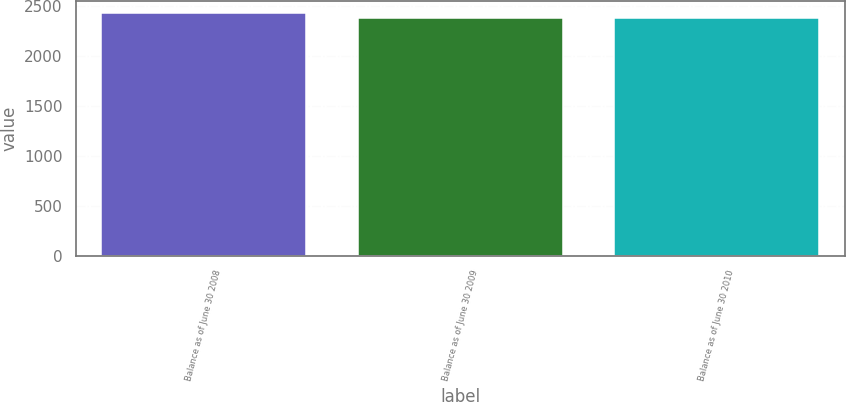Convert chart. <chart><loc_0><loc_0><loc_500><loc_500><bar_chart><fcel>Balance as of June 30 2008<fcel>Balance as of June 30 2009<fcel>Balance as of June 30 2010<nl><fcel>2426.7<fcel>2375.5<fcel>2383.3<nl></chart> 